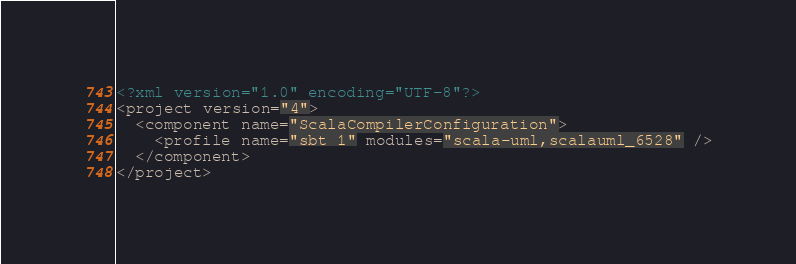Convert code to text. <code><loc_0><loc_0><loc_500><loc_500><_XML_><?xml version="1.0" encoding="UTF-8"?>
<project version="4">
  <component name="ScalaCompilerConfiguration">
    <profile name="sbt 1" modules="scala-uml,scalauml_6528" />
  </component>
</project></code> 